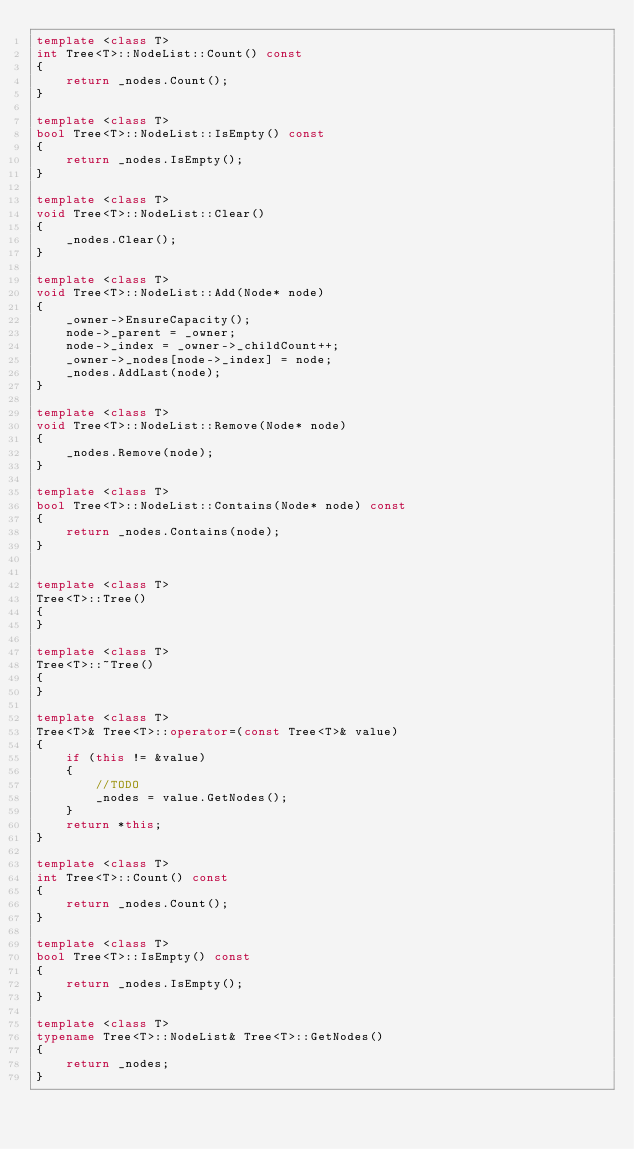<code> <loc_0><loc_0><loc_500><loc_500><_C++_>template <class T>
int Tree<T>::NodeList::Count() const
{
	return _nodes.Count();
}

template <class T>
bool Tree<T>::NodeList::IsEmpty() const
{
	return _nodes.IsEmpty();
}

template <class T>
void Tree<T>::NodeList::Clear()
{
	_nodes.Clear();
}

template <class T>
void Tree<T>::NodeList::Add(Node* node)
{
	_owner->EnsureCapacity();
	node->_parent = _owner;
	node->_index = _owner->_childCount++;
	_owner->_nodes[node->_index] = node;
	_nodes.AddLast(node);
}

template <class T>
void Tree<T>::NodeList::Remove(Node* node)
{
	_nodes.Remove(node);
}

template <class T>
bool Tree<T>::NodeList::Contains(Node* node) const
{
	return _nodes.Contains(node);
}


template <class T>
Tree<T>::Tree()
{
}

template <class T>
Tree<T>::~Tree()
{
}

template <class T>
Tree<T>& Tree<T>::operator=(const Tree<T>& value)
{
	if (this != &value)
	{
		//TODO
		_nodes = value.GetNodes();
	}
	return *this;
}

template <class T>
int Tree<T>::Count() const
{
	return _nodes.Count();
}

template <class T>
bool Tree<T>::IsEmpty() const
{
	return _nodes.IsEmpty();
}

template <class T>
typename Tree<T>::NodeList& Tree<T>::GetNodes()
{
	return _nodes;
}
</code> 